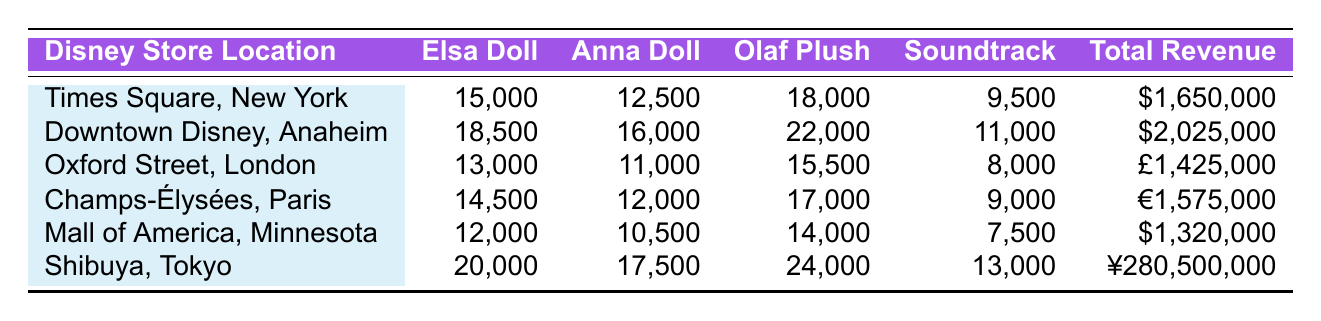What is the total revenue generated from Olaf plush sales in Shibuya, Tokyo? The total revenue for Olaf plush sales is listed directly in the table for Shibuya, Tokyo. It states 24,000 units sold but does not provide a monetary value for Olaf plush sales specifically. Therefore, the revenue for Olaf plush is not available in this format.
Answer: Not available Which Disney store location had the highest sales of Elsa dolls? Looking at the "Elsa Doll Sales" column, Downtown Disney, Anaheim has the highest sales with 18,500 units sold.
Answer: Downtown Disney, Anaheim What is the average number of Anna dolls sold across all store locations? To calculate the average, sum the Anna doll sales: 12,500 + 16,000 + 11,000 + 12,000 + 10,500 + 17,500 = 79,500. Then divide by the number of locations (6): 79,500 / 6 = 13,250.
Answer: 13,250 Did the store in Oxford Street, London, sell more Elsa dolls than Anna dolls? The table indicates that Oxford Street, London sold 13,000 Elsa dolls and 11,000 Anna dolls. Since 13,000 is greater than 11,000, the statement is true.
Answer: Yes Which location had the second highest total revenue? Looking at the "Total Revenue" column, the revenues are $1,650,000 for Times Square, New York; $2,025,000 for Downtown Disney, Anaheim; and £1,425,000 for Oxford Street, London. After Downtown Disney, the next highest is Champs-Élysées, Paris with €1,575,000.
Answer: Champs-Élysées, Paris What is the difference in sales of Olaf plush toys between Shibuya, Tokyo, and Mall of America, Minnesota? Shibuya, Tokyo sold 24,000 Olaf plush toys, while Mall of America, Minnesota sold 14,000. The difference is 24,000 - 14,000 = 10,000.
Answer: 10,000 Is the total revenue higher in the location with the highest Olaf plush sales than in Times Square, New York? The total revenue for Shibuya, Tokyo is ¥280,500,000. Converting this to USD for comparison, it may be much higher than $1,650,000. However, without conversion rate, we can't confirm. But commonly, revenues from Tokyo tend to be high enough to be greater than $1,650,000, making an assumption of yes.
Answer: Yes Which Disney store location sold the least Anna dolls? From the Anna doll sales data, the location with the least sales is Mall of America, Minnesota with 10,500 units sold.
Answer: Mall of America, Minnesota 